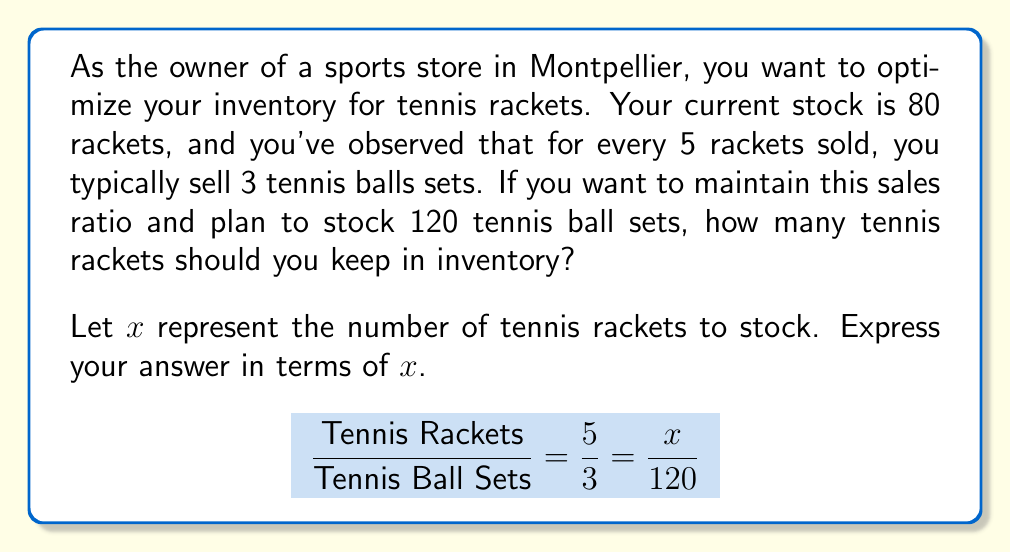Solve this math problem. Let's solve this step-by-step:

1) We know that the ratio of tennis rackets to tennis ball sets is 5:3.
   This can be expressed as a fraction: $\frac{5}{3}$

2) We want to maintain this ratio with our new inventory. So we can set up a proportion:

   $$\frac{5}{3} = \frac{x}{120}$$

   Where $x$ is the number of tennis rackets we need to stock.

3) To solve for $x$, we can cross-multiply:

   $$5 \cdot 120 = 3x$$

4) Simplify the left side:

   $$600 = 3x$$

5) Divide both sides by 3:

   $$\frac{600}{3} = x$$

6) Simplify:

   $$200 = x$$

Therefore, to maintain the sales ratio of 5 rackets for every 3 tennis ball sets, you should stock 200 tennis rackets when you have 120 tennis ball sets in inventory.
Answer: 200 rackets 